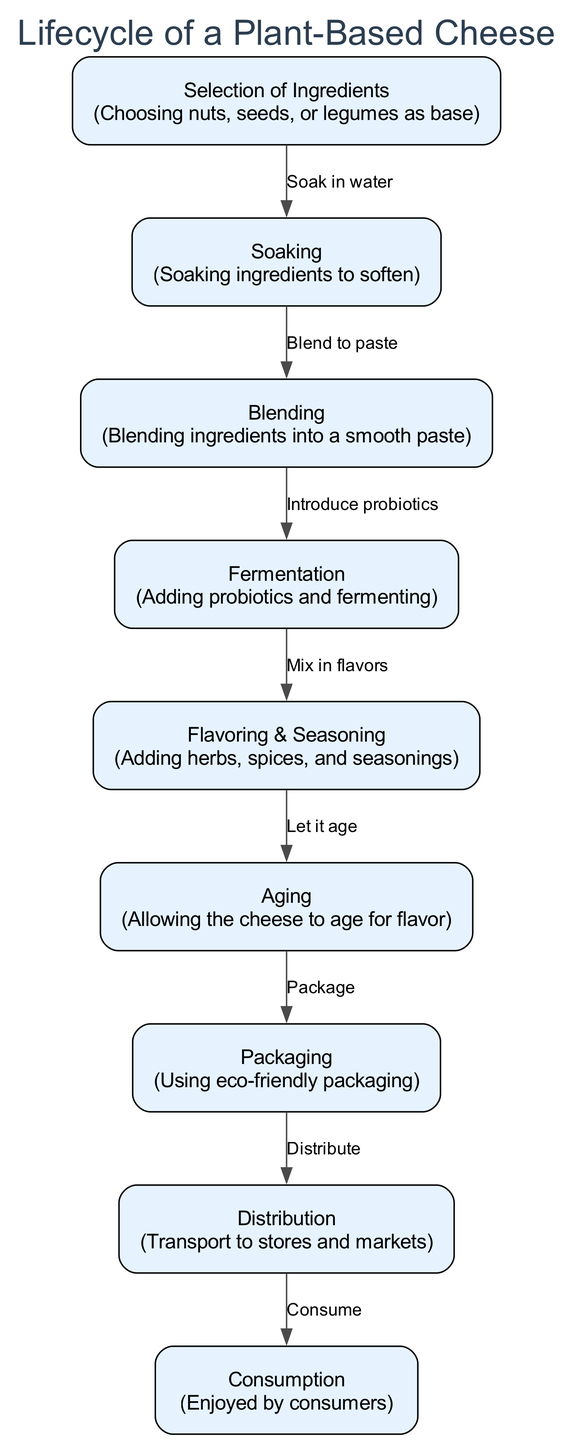What is the first step in the lifecycle? The first step listed in the lifecycle is "Selection of Ingredients." This is indicated as the starting node in the diagram with the label at the top of the flow.
Answer: Selection of Ingredients How many nodes are there in the lifecycle? By counting each distinct labeled step in the diagram, there are a total of 9 nodes present. Each node represents a different stage in the lifecycle of plant-based cheese.
Answer: 9 What is the final node of the process? The final node in the diagram is "Consumption," which represents the end of the lifecycle where the cheese is enjoyed by consumers. This node is at the bottom of the flow.
Answer: Consumption What process comes after fermentation? The diagram indicates that "Flavoring & Seasoning" follows "Fermentation," meaning that after fermenting the cheese, flavors are added. This is shown as a direct edge in the flow from one node to the next.
Answer: Flavoring & Seasoning Which step involves eco-friendly practices? The step that involves eco-friendly practices is "Packaging," where the plant-based cheese is packaged using environmentally friendly materials, as mentioned in the description of that node.
Answer: Packaging How many edges connect the nodes in the lifecycle? By analyzing the connections between the nodes, there are 8 edges shown in the diagram, indicating the flow from one step to the next in the lifecycle process.
Answer: 8 What is added during the fermentation stage? "Probiotics" are introduced during the fermentation stage as indicated in the diagram. This addition is necessary for the fermentation process to occur.
Answer: Probiotics What follows the aging step? After "Aging," the next step is "Packaging." This indicates that the cheese is packaged once it reaches the desired flavor through the aging process.
Answer: Packaging 